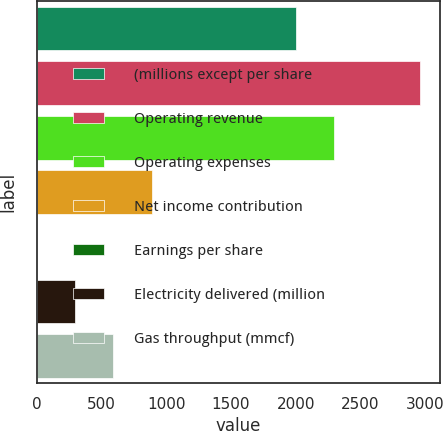Convert chart to OTSL. <chart><loc_0><loc_0><loc_500><loc_500><bar_chart><fcel>(millions except per share<fcel>Operating revenue<fcel>Operating expenses<fcel>Net income contribution<fcel>Earnings per share<fcel>Electricity delivered (million<fcel>Gas throughput (mmcf)<nl><fcel>2001<fcel>2963<fcel>2297.16<fcel>889.92<fcel>1.45<fcel>297.61<fcel>593.77<nl></chart> 